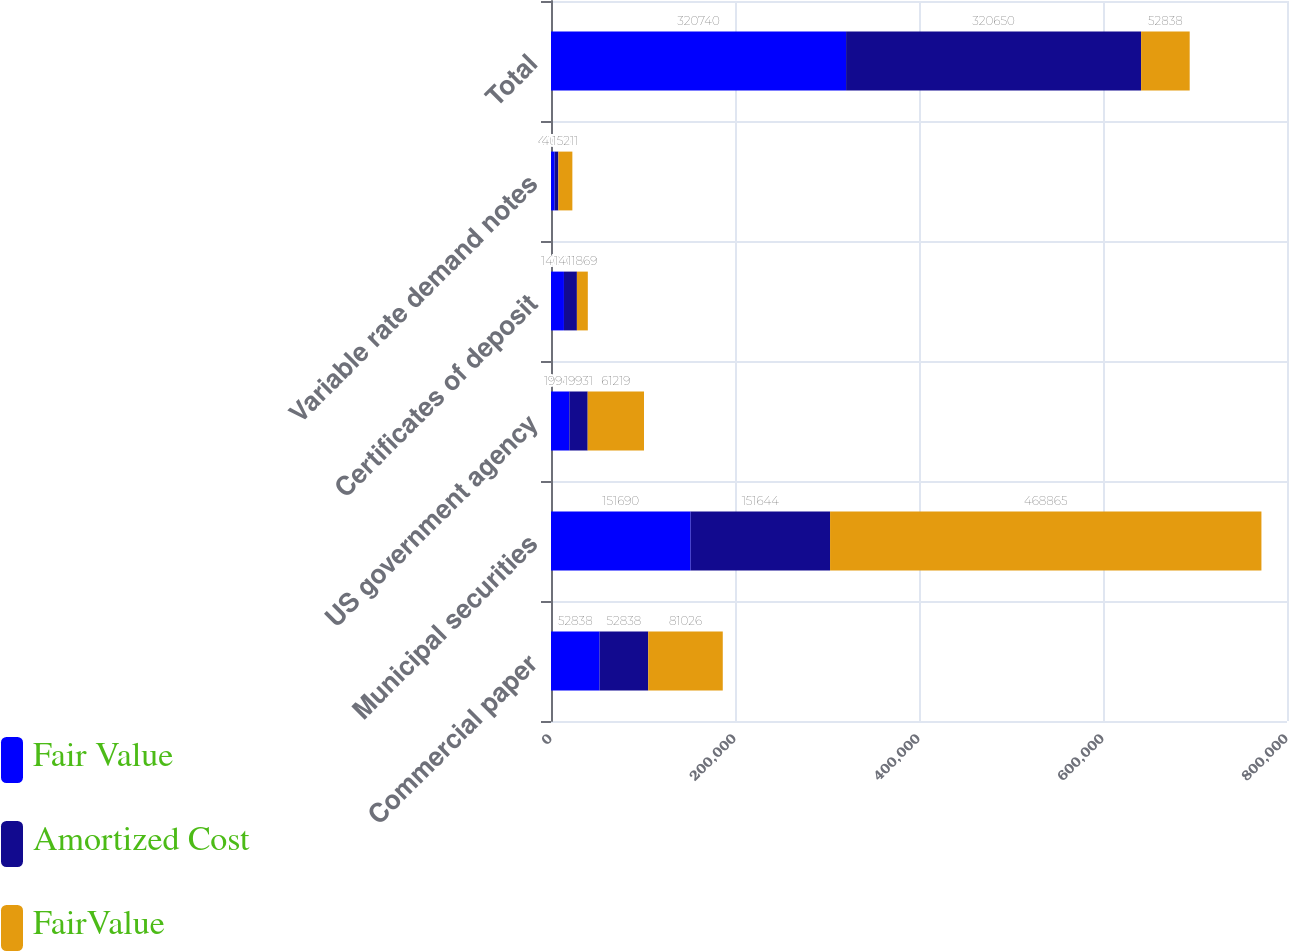Convert chart. <chart><loc_0><loc_0><loc_500><loc_500><stacked_bar_chart><ecel><fcel>Commercial paper<fcel>Municipal securities<fcel>US government agency<fcel>Certificates of deposit<fcel>Variable rate demand notes<fcel>Total<nl><fcel>Fair Value<fcel>52838<fcel>151690<fcel>19943<fcel>14075<fcel>4005<fcel>320740<nl><fcel>Amortized Cost<fcel>52838<fcel>151644<fcel>19931<fcel>14075<fcel>4005<fcel>320650<nl><fcel>FairValue<fcel>81026<fcel>468865<fcel>61219<fcel>11869<fcel>15211<fcel>52838<nl></chart> 